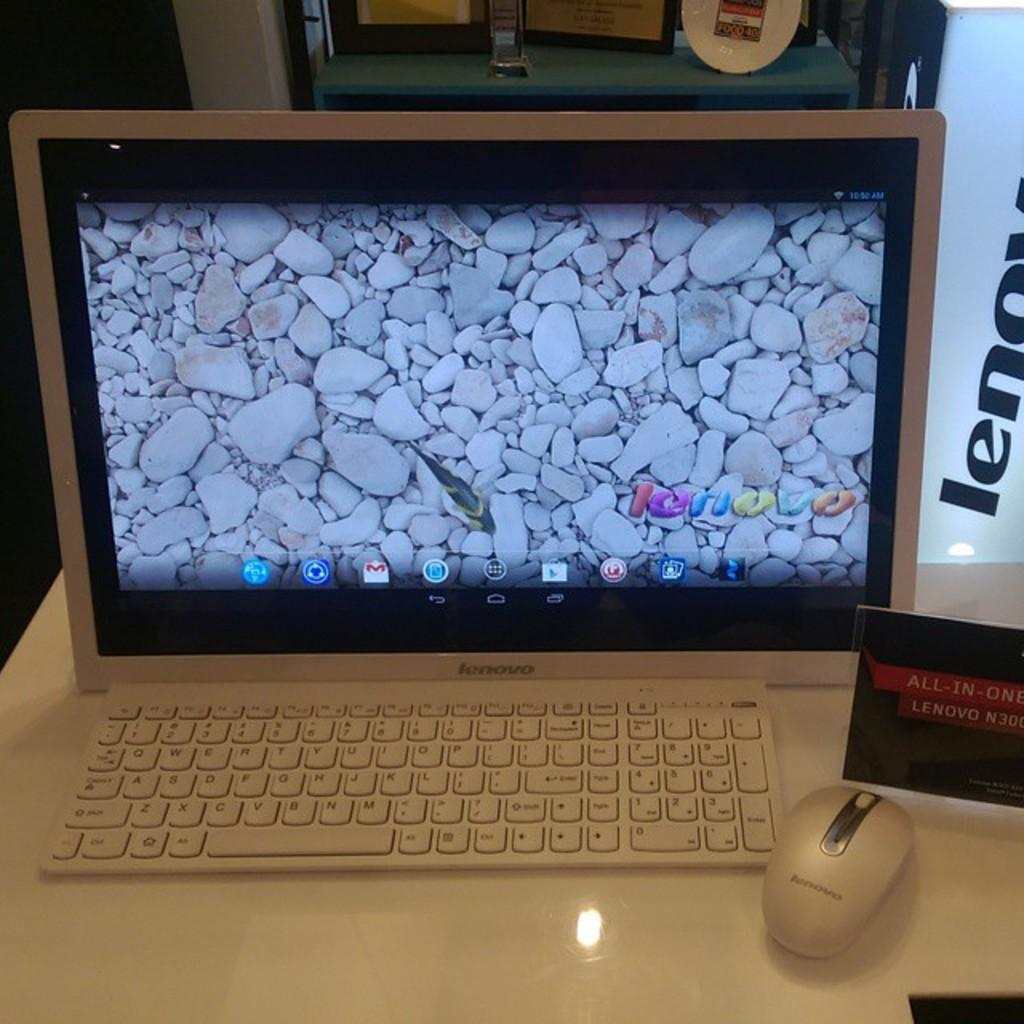<image>
Write a terse but informative summary of the picture. The Lenovo monitor displays what looks like the rocky bottom of a fish tank with a fish swimming by. 